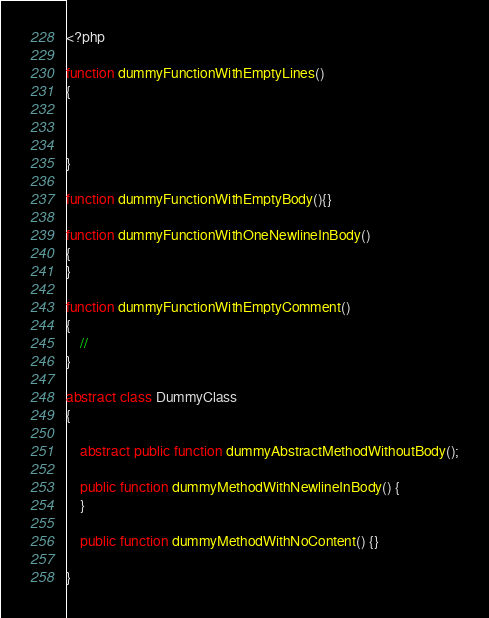<code> <loc_0><loc_0><loc_500><loc_500><_PHP_><?php

function dummyFunctionWithEmptyLines()
{



}

function dummyFunctionWithEmptyBody(){}

function dummyFunctionWithOneNewlineInBody()
{
}

function dummyFunctionWithEmptyComment()
{
	//
}

abstract class DummyClass
{

	abstract public function dummyAbstractMethodWithoutBody();

	public function dummyMethodWithNewlineInBody() {
	}

	public function dummyMethodWithNoContent() {}

}
</code> 